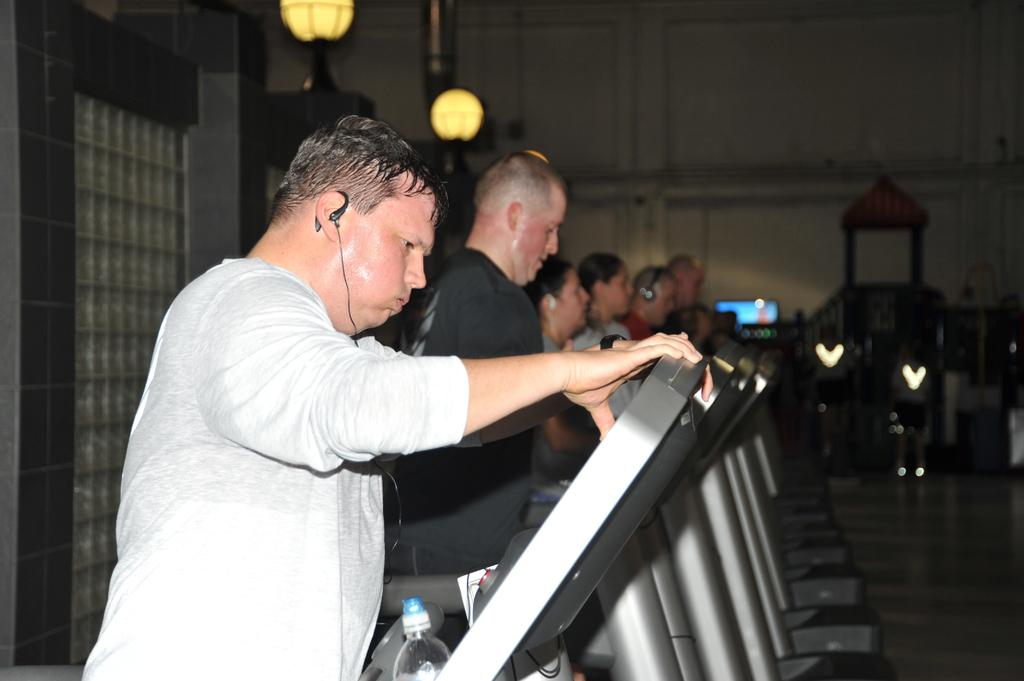What can be seen in the image? There are people and treadmills in the image. Can you describe the lighting in the image? There is light in the image. What is the background of the image like? There is a wall in the image. Is there anyone in the image who is listening to music? Yes, there is a person listening to music in the image. What items can be seen that might be used for hydration or carrying personal belongings? There is a water bottle and a bag in the image. What type of curtain can be seen in the image? There is no curtain present in the image. How does the person express their love for the treadmill in the image? The image does not show any expression of love for the treadmill; it simply depicts people using them. 